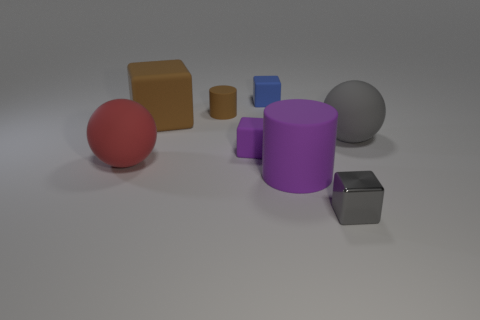Is there any other thing that is the same material as the small gray thing?
Your response must be concise. No. There is a matte thing to the right of the big purple cylinder; does it have the same color as the small block that is right of the small blue matte cube?
Offer a terse response. Yes. Are there any small cylinders made of the same material as the big brown block?
Your answer should be compact. Yes. There is a gray thing in front of the red thing that is on the left side of the small blue object; what is its size?
Your response must be concise. Small. Is the number of gray rubber things greater than the number of matte balls?
Provide a succinct answer. No. Is the size of the gray object behind the gray metal block the same as the small metallic thing?
Offer a terse response. No. How many large cylinders are the same color as the small shiny cube?
Offer a very short reply. 0. Do the tiny purple thing and the red object have the same shape?
Your answer should be very brief. No. Is there anything else that is the same size as the brown matte cylinder?
Your response must be concise. Yes. What is the size of the brown rubber thing that is the same shape as the large purple thing?
Keep it short and to the point. Small. 